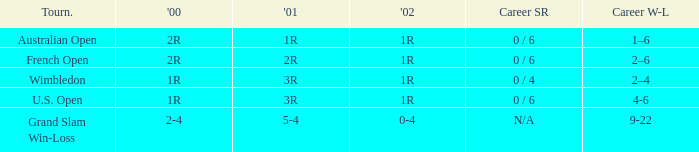In what year 2000 tournment did Angeles Montolio have a career win-loss record of 2-4? Grand Slam Win-Loss. 